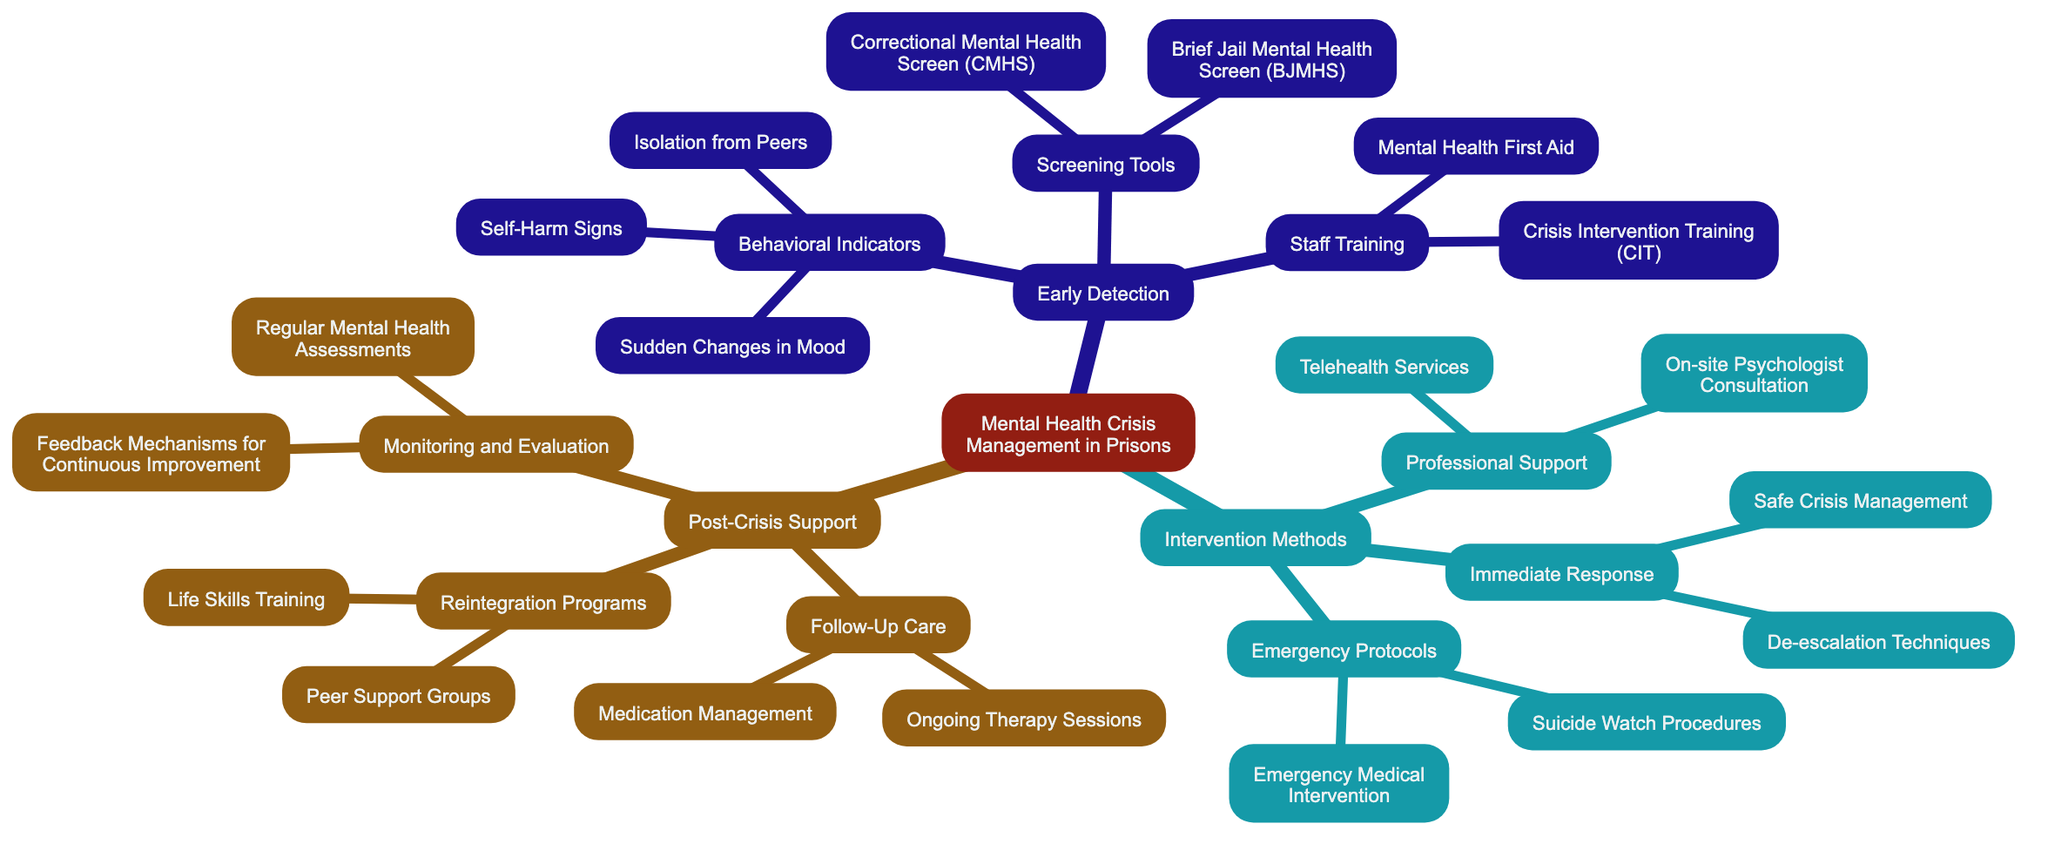What are the behavioral indicators of early detection? The diagram lists several behavioral indicators under "Early Detection" in the "Behavioral Indicators" section. These indicators include "Sudden Changes in Mood," "Isolation from Peers," and "Self-Harm Signs."
Answer: Sudden Changes in Mood, Isolation from Peers, Self-Harm Signs How many screening tools are listed? Under "Early Detection," there are two sub-nodes under "Screening Tools": "Brief Jail Mental Health Screen (BJMHS)" and "Correctional Mental Health Screen (CMHS)." Counting these nodes gives a total of two screening tools.
Answer: 2 What intervention method is associated with immediate response? The diagram indicates "Immediate Response" under "Intervention Methods" and lists "De-escalation Techniques" and "Safe Crisis Management" as examples. One direct method listed here is "De-escalation Techniques."
Answer: De-escalation Techniques What types of post-crisis support are mentioned? The "Post-Crisis Support" section of the diagram includes several categories: "Follow-Up Care," "Reintegration Programs," and "Monitoring and Evaluation." Each category may include various support techniques. The first visible category is "Follow-Up Care."
Answer: Follow-Up Care Which professional support method includes telehealth services? In the "Intervention Methods" section, under "Professional Support," "Telehealth Services" is specifically listed along with on-site psychologist consultation. This indicates the presence of telehealth services as a professional support method.
Answer: Telehealth Services What are the feedback mechanisms for continuous improvement? Under "Monitoring and Evaluation," the diagram outlines "Regular Mental Health Assessments" and "Feedback Mechanisms for Continuous Improvement" as methods for this category. The specific feedback mechanism mentioned is "Feedback Mechanisms for Continuous Improvement."
Answer: Feedback Mechanisms for Continuous Improvement Which type of training is mentioned under staff training? The "Staff Training" section lists two specific types: "Mental Health First Aid" and "Crisis Intervention Training (CIT)." Both represent essential training types provided to staff, with "Crisis Intervention Training (CIT)" being one of them.
Answer: Crisis Intervention Training (CIT) What is an example of emergency protocol? Under the "Emergency Protocols" section of "Intervention Methods," "Suicide Watch Procedures" and "Emergency Medical Intervention" are identified. Searching through these options, "Suicide Watch Procedures" is an example of an emergency protocol.
Answer: Suicide Watch Procedures 